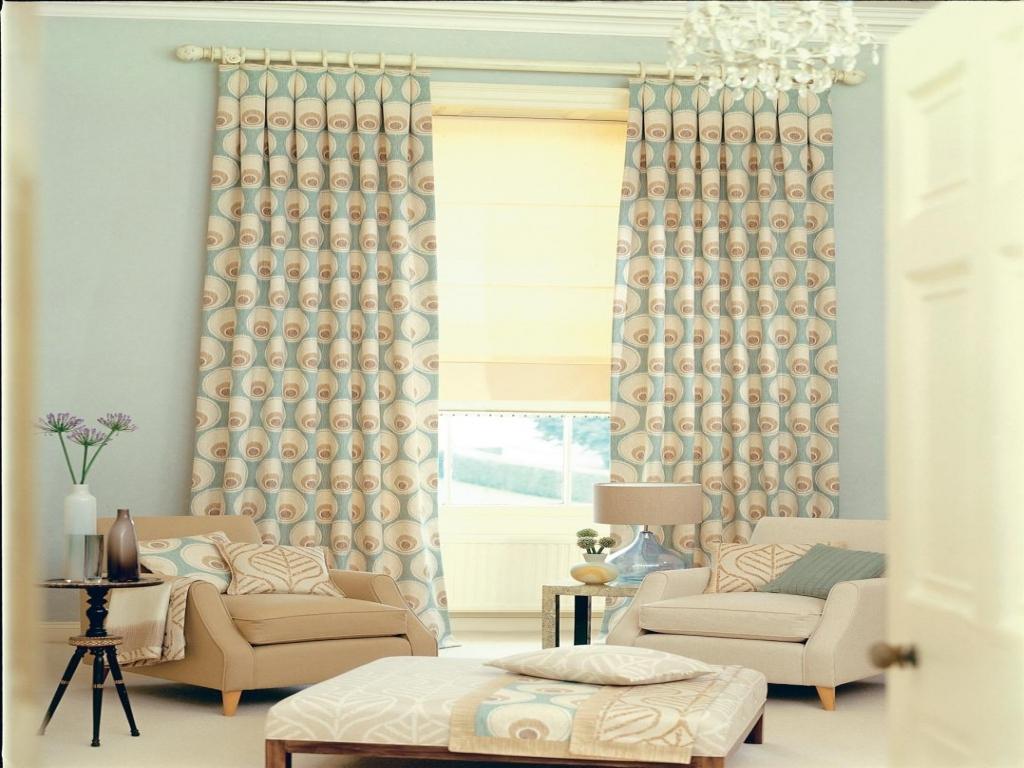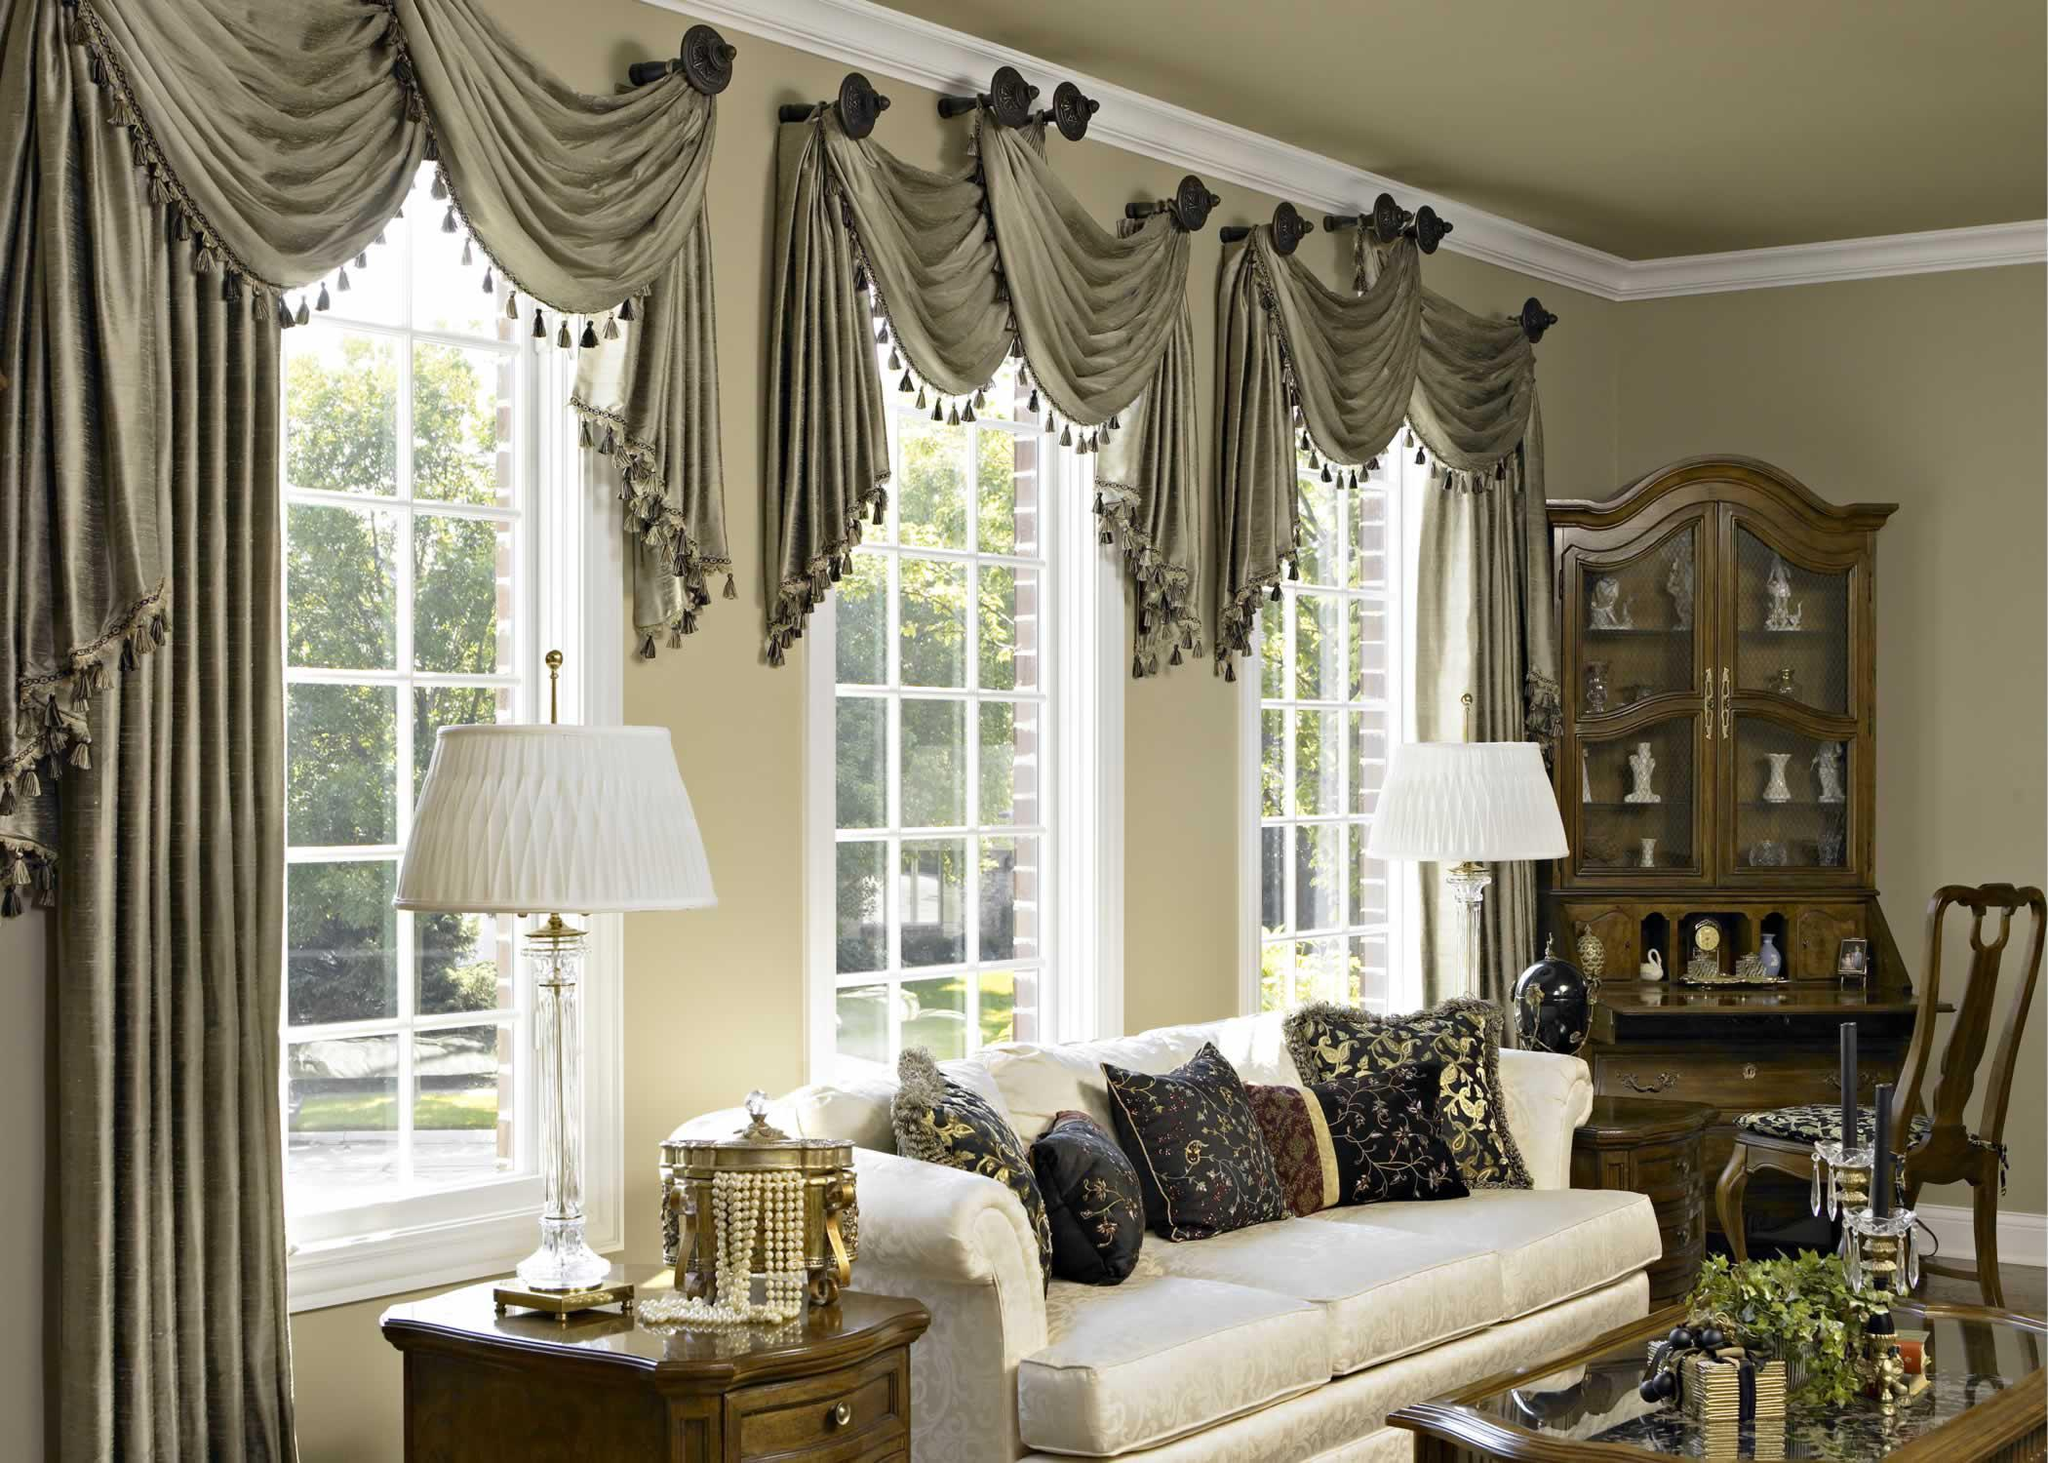The first image is the image on the left, the second image is the image on the right. Given the left and right images, does the statement "One set of curtains is closed." hold true? Answer yes or no. No. The first image is the image on the left, the second image is the image on the right. Given the left and right images, does the statement "Sheer white drapes hang from a black horizontal bar in a white room with seating furniture, in one image." hold true? Answer yes or no. No. 